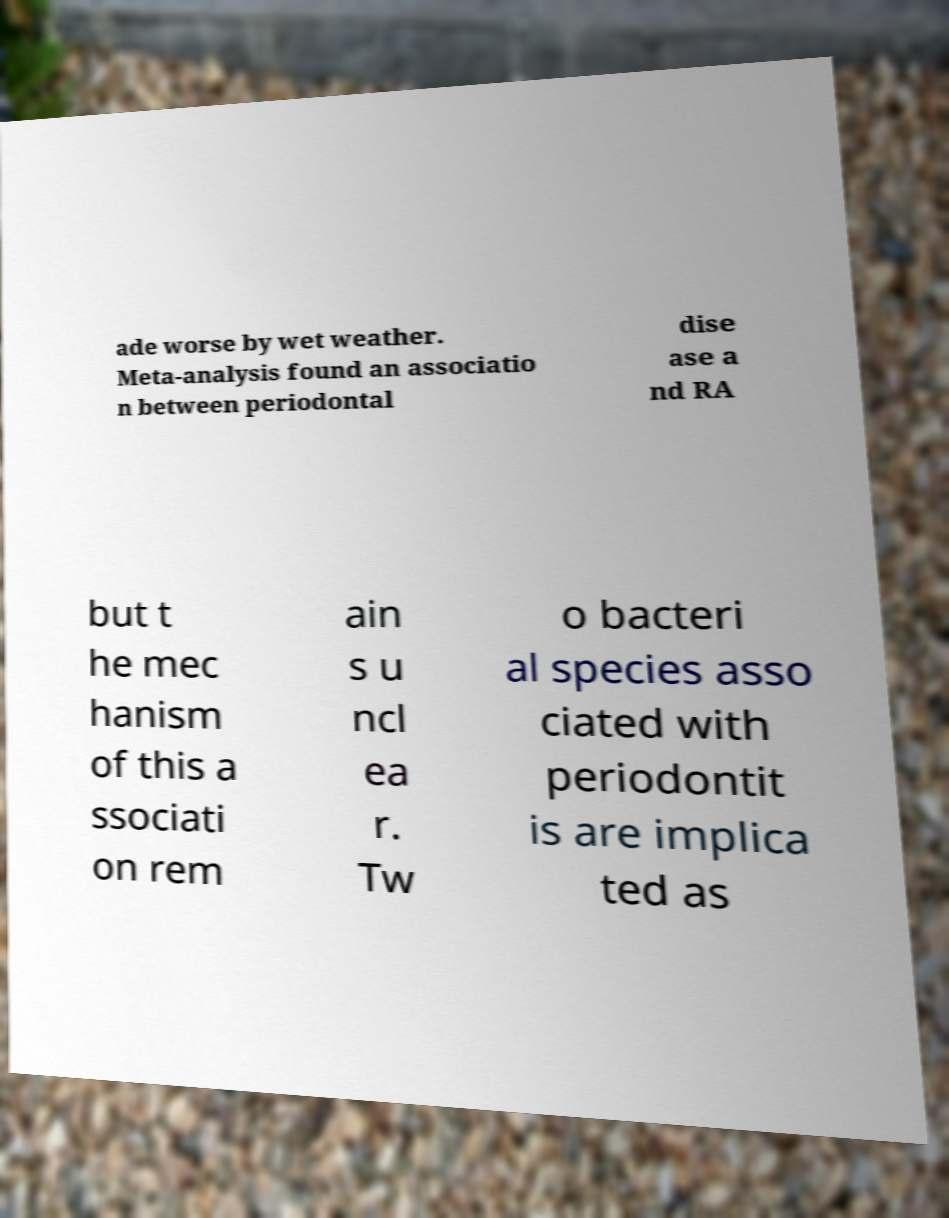Please read and relay the text visible in this image. What does it say? ade worse by wet weather. Meta-analysis found an associatio n between periodontal dise ase a nd RA but t he mec hanism of this a ssociati on rem ain s u ncl ea r. Tw o bacteri al species asso ciated with periodontit is are implica ted as 